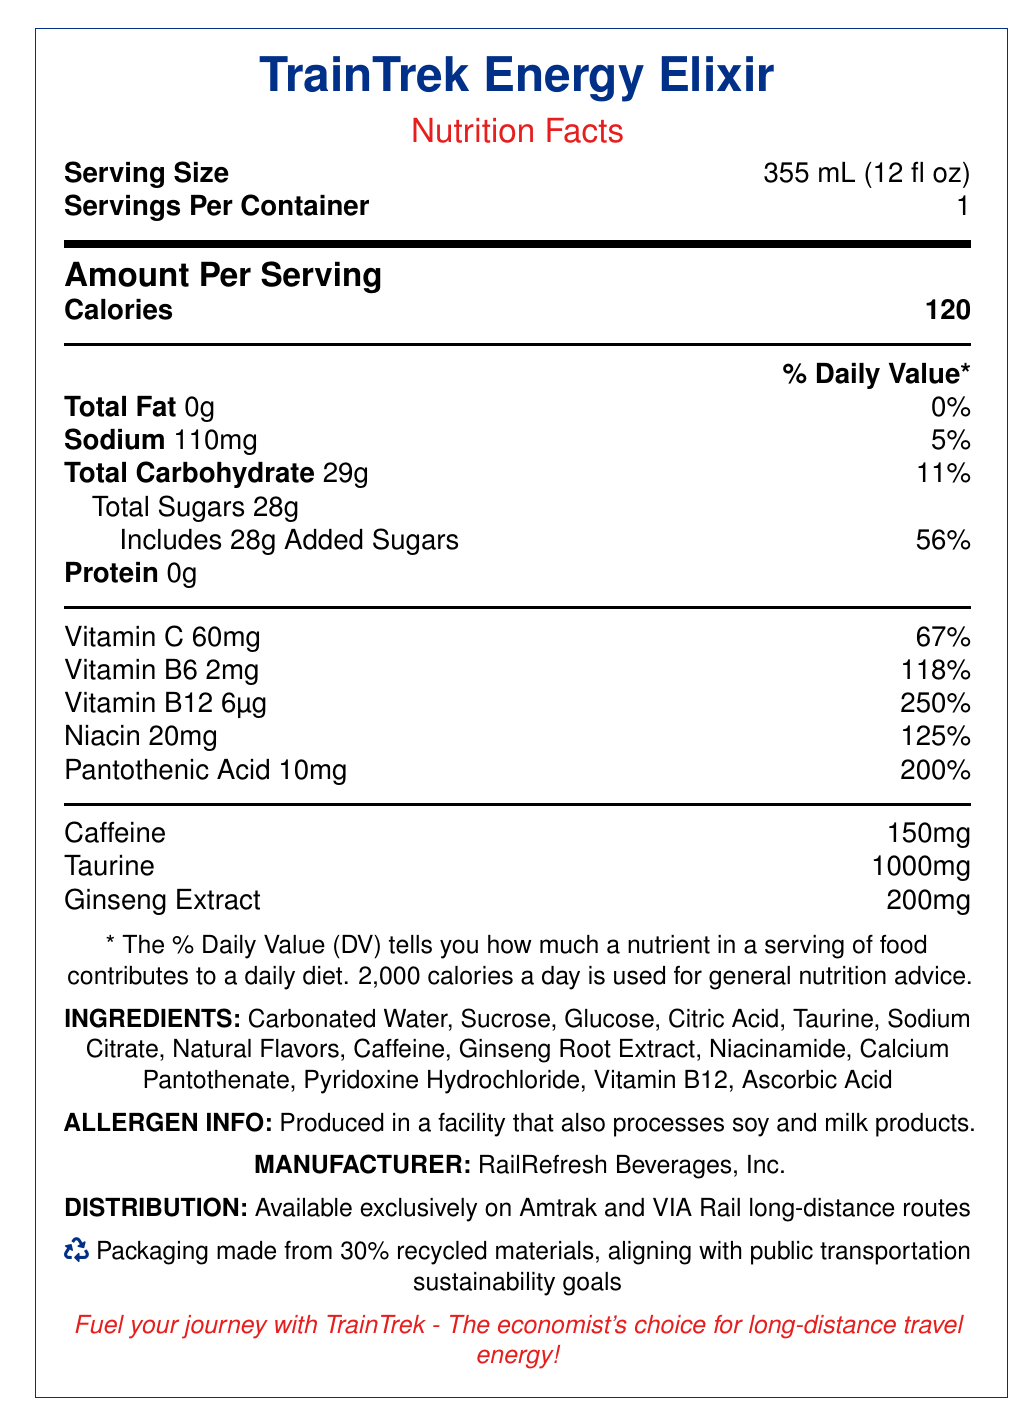what is the serving size? The serving size is clearly stated at the top of the nutrition facts section: "Serving Size 355 mL (12 fl oz)."
Answer: 355 mL (12 fl oz) how many calories are in one serving? The calories per serving are listed prominently in bold under the "Amount Per Serving" section.
Answer: 120 how much total fat does this drink contain? The total fat content is listed under "Total Fat" as 0g with a daily value of 0%.
Answer: 0g how much sodium is in one serving? The sodium content is specified as 110mg in the nutrition facts table.
Answer: 110mg what is the percentage of daily value for added sugars? The added sugars amount to 28g and the percentage of daily value is given as 56%.
Answer: 56% how much protein is in the product? The protein content is listed as 0g in the nutrition facts table.
Answer: 0g how much caffeine does the product contain? The caffeine content is listed separately under the nutrition section without a percentage daily value.
Answer: 150mg what are the main ingredients in this beverage? A. Water, Sugar, Citric Acid B. Carbonated Water, Sucrose, Glucose C. Water, Caffeine, Ginseng Extract D. Carbonated Water, Sodium Citrate, Ascorbic Acid The main ingredients listed are "Carbonated Water, Sucrose, Glucose."
Answer: B who is the manufacturer of this product? A. Amtrak B. VIA Rail C. RailRefresh Beverages, Inc. D. TrainTrek Enterprises The document states that "RailRefresh Beverages, Inc." is the manufacturer.
Answer: C is the product's packaging environmentally friendly? The sustainability note mentions that the packaging is made from 30% recycled materials, aligning with public transportation sustainability goals.
Answer: Yes summarize the nutrition facts label for TrainTrek Energy Elixir. The document outlines the nutritional content of TrainTrek Energy Elixir, emphasizing vitamins and ingredients, while highlighting its sustainable packaging and exclusive availability on specific train routes.
Answer: The document provides detailed nutritional information for TrainTrek Energy Elixir, a fortified beverage aimed at reducing fatigue in long-distance train passengers. It includes data on serving size, calories, fats, sodium, carbohydrates, sugars, proteins, and various vitamins. It also highlights caffeine, taurine, and ginseng extract contents. Additional information about ingredients, allergen info, manufacturer, and distribution is given. The document underscores the sustainability of the product's packaging. what is the origin of the ingredients used in the beverage? The document does not provide information about the origin of the ingredients.
Answer: Not enough information 